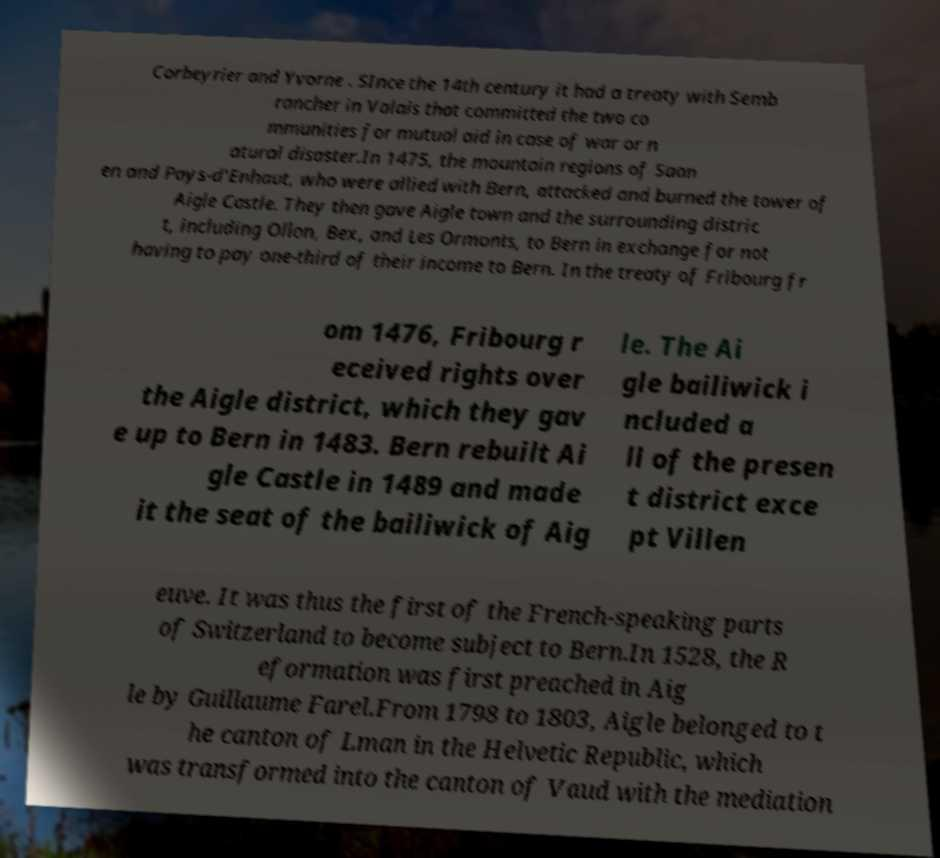What messages or text are displayed in this image? I need them in a readable, typed format. Corbeyrier and Yvorne . SInce the 14th century it had a treaty with Semb rancher in Valais that committed the two co mmunities for mutual aid in case of war or n atural disaster.In 1475, the mountain regions of Saan en and Pays-d'Enhaut, who were allied with Bern, attacked and burned the tower of Aigle Castle. They then gave Aigle town and the surrounding distric t, including Ollon, Bex, and Les Ormonts, to Bern in exchange for not having to pay one-third of their income to Bern. In the treaty of Fribourg fr om 1476, Fribourg r eceived rights over the Aigle district, which they gav e up to Bern in 1483. Bern rebuilt Ai gle Castle in 1489 and made it the seat of the bailiwick of Aig le. The Ai gle bailiwick i ncluded a ll of the presen t district exce pt Villen euve. It was thus the first of the French-speaking parts of Switzerland to become subject to Bern.In 1528, the R eformation was first preached in Aig le by Guillaume Farel.From 1798 to 1803, Aigle belonged to t he canton of Lman in the Helvetic Republic, which was transformed into the canton of Vaud with the mediation 